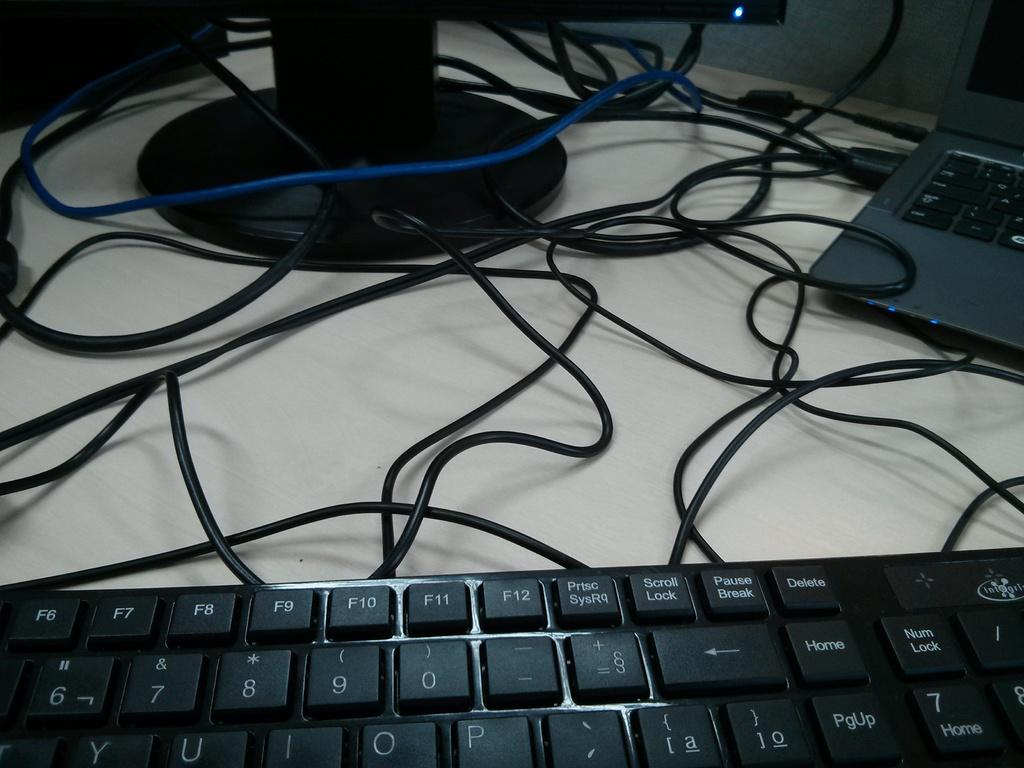<image>
Relay a brief, clear account of the picture shown. A computer monitor, a laptop, and an Integris keyboard placed on a white surface. 